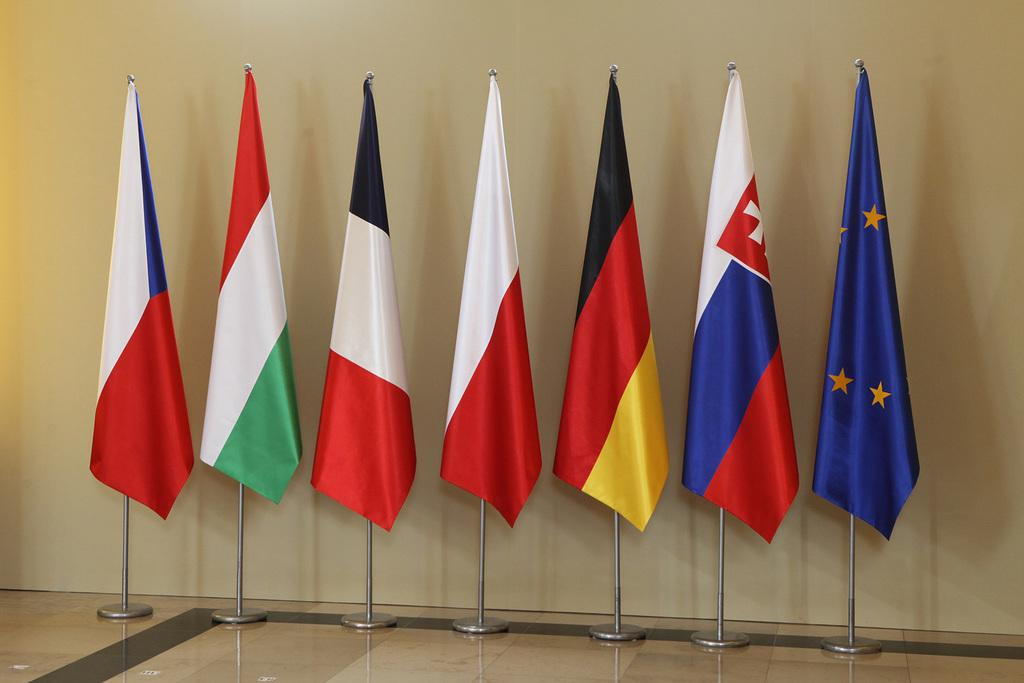What can be seen in the image? There are flags in the image. Where are the flags positioned? The flags are on a stand. What is visible behind the flags? There is a wall behind the flags. What is the title of the book held by the person in the image? There is no person or book present in the image; it only features flags on a stand and a wall in the background. 